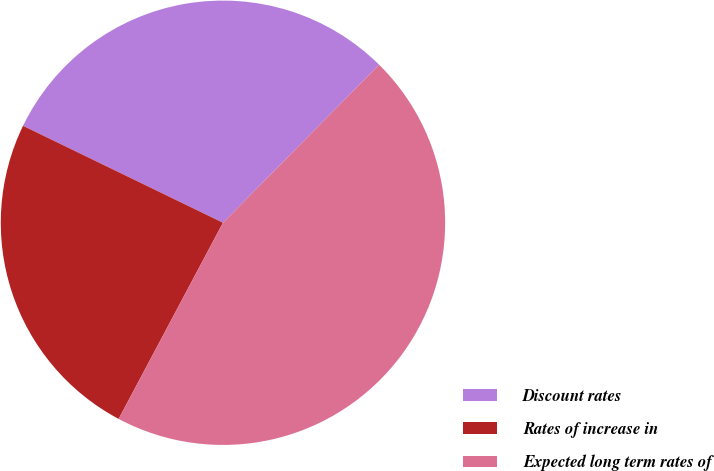Convert chart. <chart><loc_0><loc_0><loc_500><loc_500><pie_chart><fcel>Discount rates<fcel>Rates of increase in<fcel>Expected long term rates of<nl><fcel>30.22%<fcel>24.41%<fcel>45.38%<nl></chart> 